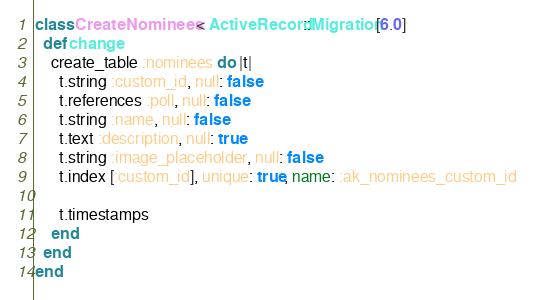Convert code to text. <code><loc_0><loc_0><loc_500><loc_500><_Ruby_>class CreateNominees < ActiveRecord::Migration[6.0]
  def change
    create_table :nominees do |t|
      t.string :custom_id, null: false
      t.references :poll, null: false
      t.string :name, null: false
      t.text :description, null: true
      t.string :image_placeholder, null: false
      t.index [:custom_id], unique: true, name: :ak_nominees_custom_id

      t.timestamps
    end
  end
end
</code> 